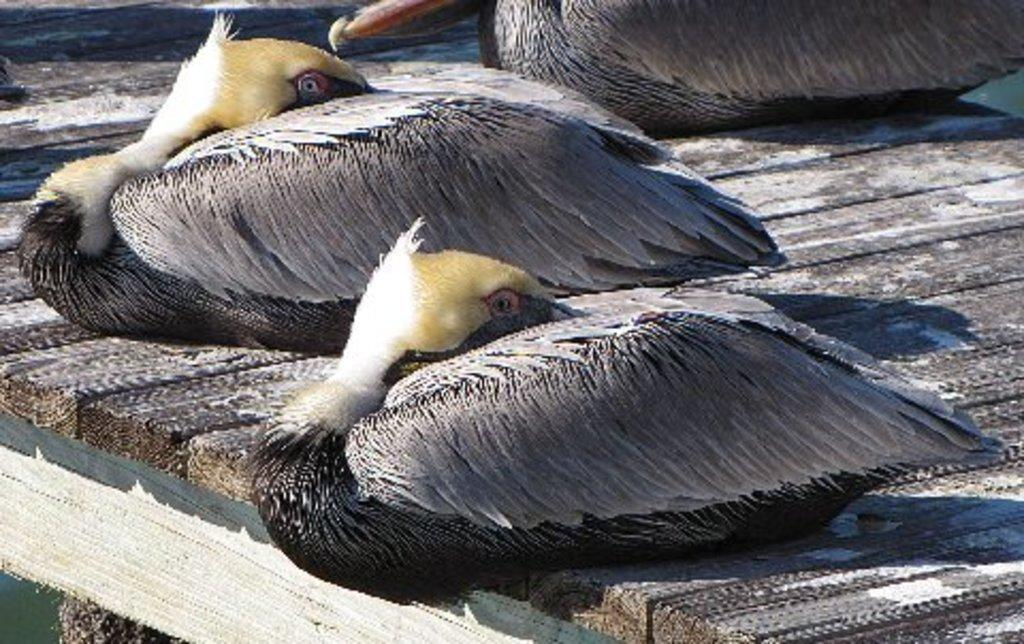What type of animals can be seen in the image? Birds can be seen in the image. Where are the birds located in the image? The birds are on a wooden surface. What type of guide is present in the image to help the birds navigate? There is no guide present in the image to help the birds navigate. 